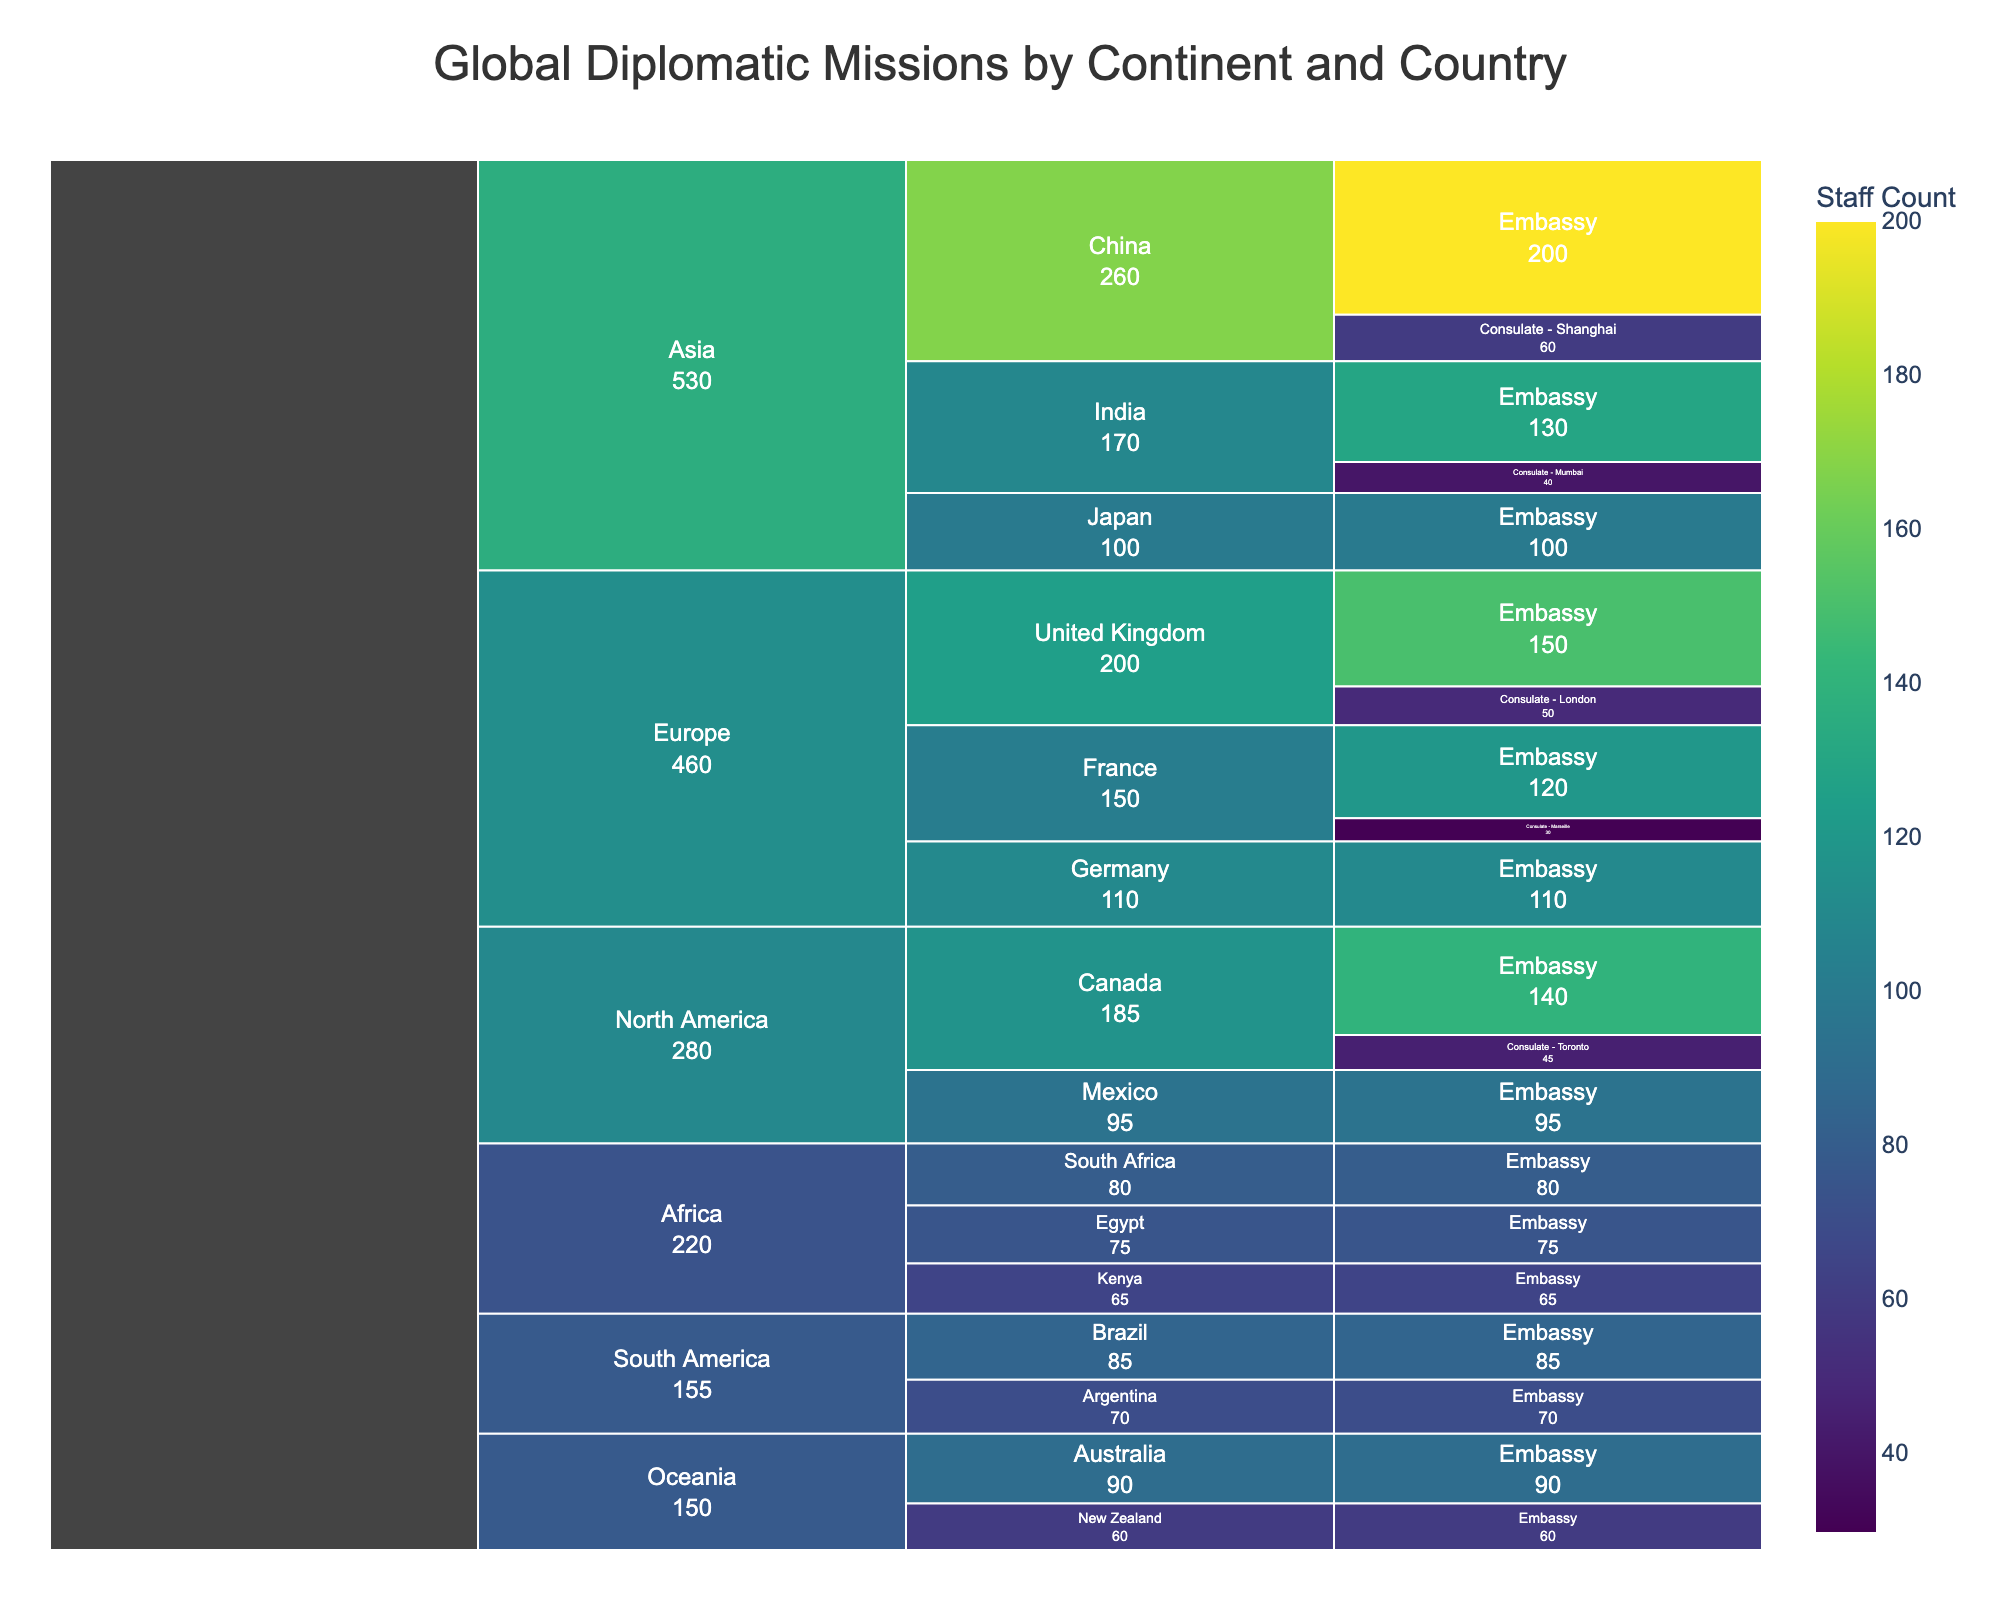What is the title of the chart? The title of the chart is typically found at the top, often in larger or bold font. Look for the text that describes the chart's content.
Answer: Global Diplomatic Missions by Continent and Country Which continent has the highest number of total staff in diplomatic missions? The icicle chart allows us to see the total number of staff by aggregating the values within each continent. Visually compare the size of each continent's section in the chart.
Answer: Asia What is the staff count of the Embassy in the United Kingdom? Drill down into Europe, find the United Kingdom, and look for the staff count associated with the "Embassy" label.
Answer: 150 Which country in Asia has the highest staff count in its diplomatic missions? Within the Asia section of the icicle chart, compare the sizes or values of the individual countries' sections to determine the one with the highest staff count.
Answer: China How many countries in Europe are included in the chart? Navigate through the Europe section and count the number of distinct country names listed.
Answer: 3 What is the difference in staff count between the Consulate in London and the Consulate in Shanghai? Locate the Consulate - London under the United Kingdom and the Consulate - Shanghai under China, then subtract the smaller staff count from the larger one (60 - 50).
Answer: 10 Which country in North America has the smallest total staff count in its diplomatic missions? In the North America section, compare the total staff counts for each country to identify the one with the smallest value.
Answer: Mexico How many diplomatic missions are listed under Australia in Oceania? Drill down into the Oceania section, locate Australia, and count the number of separate mission entries listed under it.
Answer: 1 What is the combined staff count for embassies in South America? Sum the staff counts for all the embassies listed under the South America continent: Brazil (85) and Argentina (70).
Answer: 155 Which continent shows the highest variation in staff counts among its countries? Compare the range of staff counts (difference between the highest and lowest values) for each continent to spot the one with the widest range.
Answer: Asia 